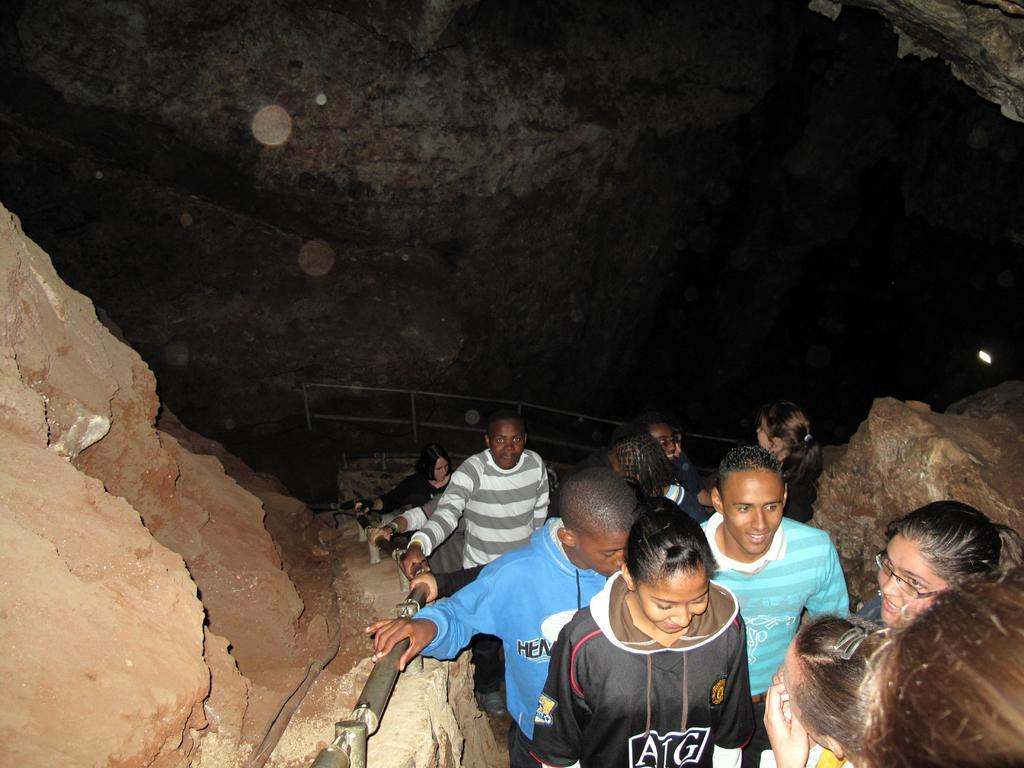What can be seen on the right side of the image? There are persons on the path on the right side of the image. What is the terrain like on both sides of the path? There are hills on both sides of the path. How would you describe the overall color scheme of the image? The background of the image is dark in color. Is there any honey dripping from the trees in the image? There is no honey or trees mentioned in the image, so it cannot be determined if honey is present. How hot is the temperature in the image? The provided facts do not mention the temperature, so it cannot be determined from the image. 